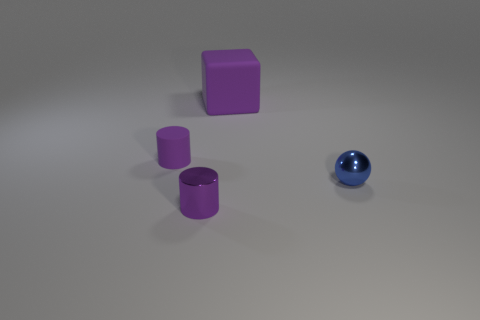Subtract all blue cylinders. Subtract all yellow blocks. How many cylinders are left? 2 Subtract all purple balls. How many brown cubes are left? 0 Add 1 large cyans. How many things exist? 0 Subtract all green shiny objects. Subtract all purple cylinders. How many objects are left? 2 Add 4 purple matte things. How many purple matte things are left? 6 Add 1 big yellow metal cylinders. How many big yellow metal cylinders exist? 1 Add 3 small brown metal balls. How many objects exist? 7 Subtract 0 brown blocks. How many objects are left? 4 Subtract all purple cylinders. How many were subtracted if there are1purple cylinders left? 1 Subtract all spheres. How many objects are left? 3 